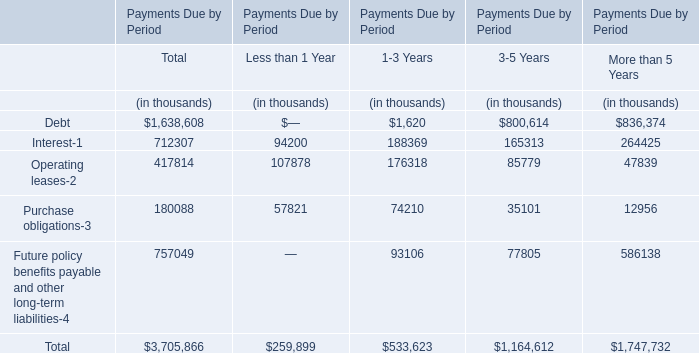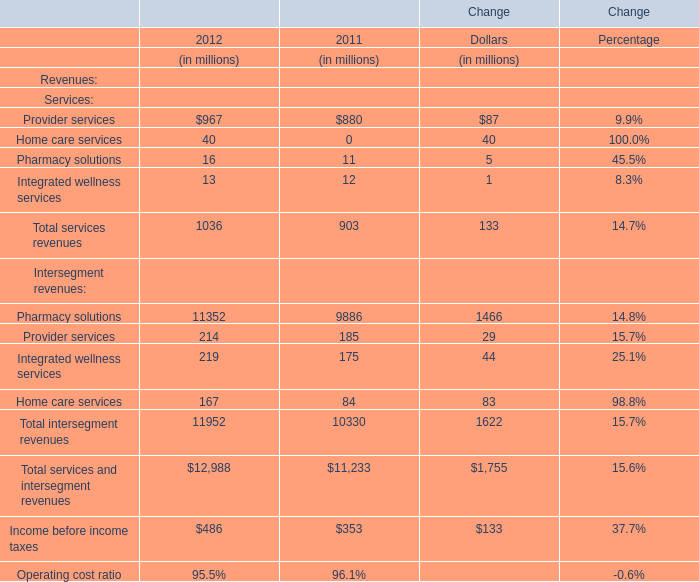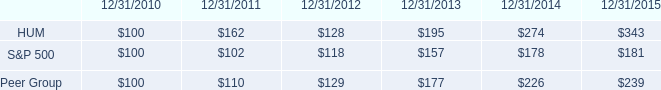what was the percent of the decline in the stock price performance for hum from 2011 to 2012 
Computations: ((128 / 162) / 162)
Answer: 0.00488. 